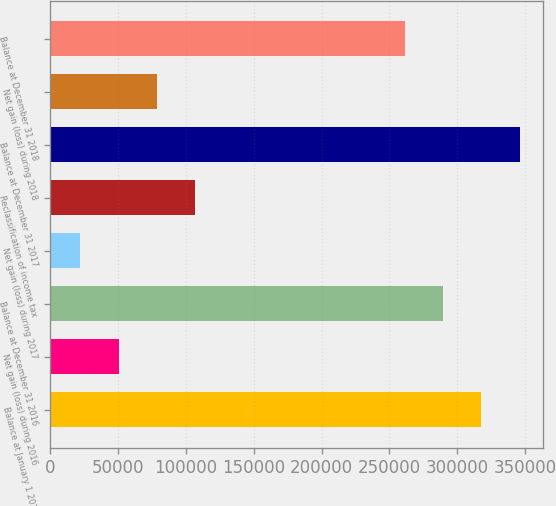<chart> <loc_0><loc_0><loc_500><loc_500><bar_chart><fcel>Balance at January 1 2016<fcel>Net gain (loss) during 2016<fcel>Balance at December 31 2016<fcel>Net gain (loss) during 2017<fcel>Reclassification of income tax<fcel>Balance at December 31 2017<fcel>Net gain (loss) during 2018<fcel>Balance at December 31 2018<nl><fcel>317755<fcel>50513.8<fcel>289529<fcel>22288<fcel>106965<fcel>345980<fcel>78739.6<fcel>261303<nl></chart> 